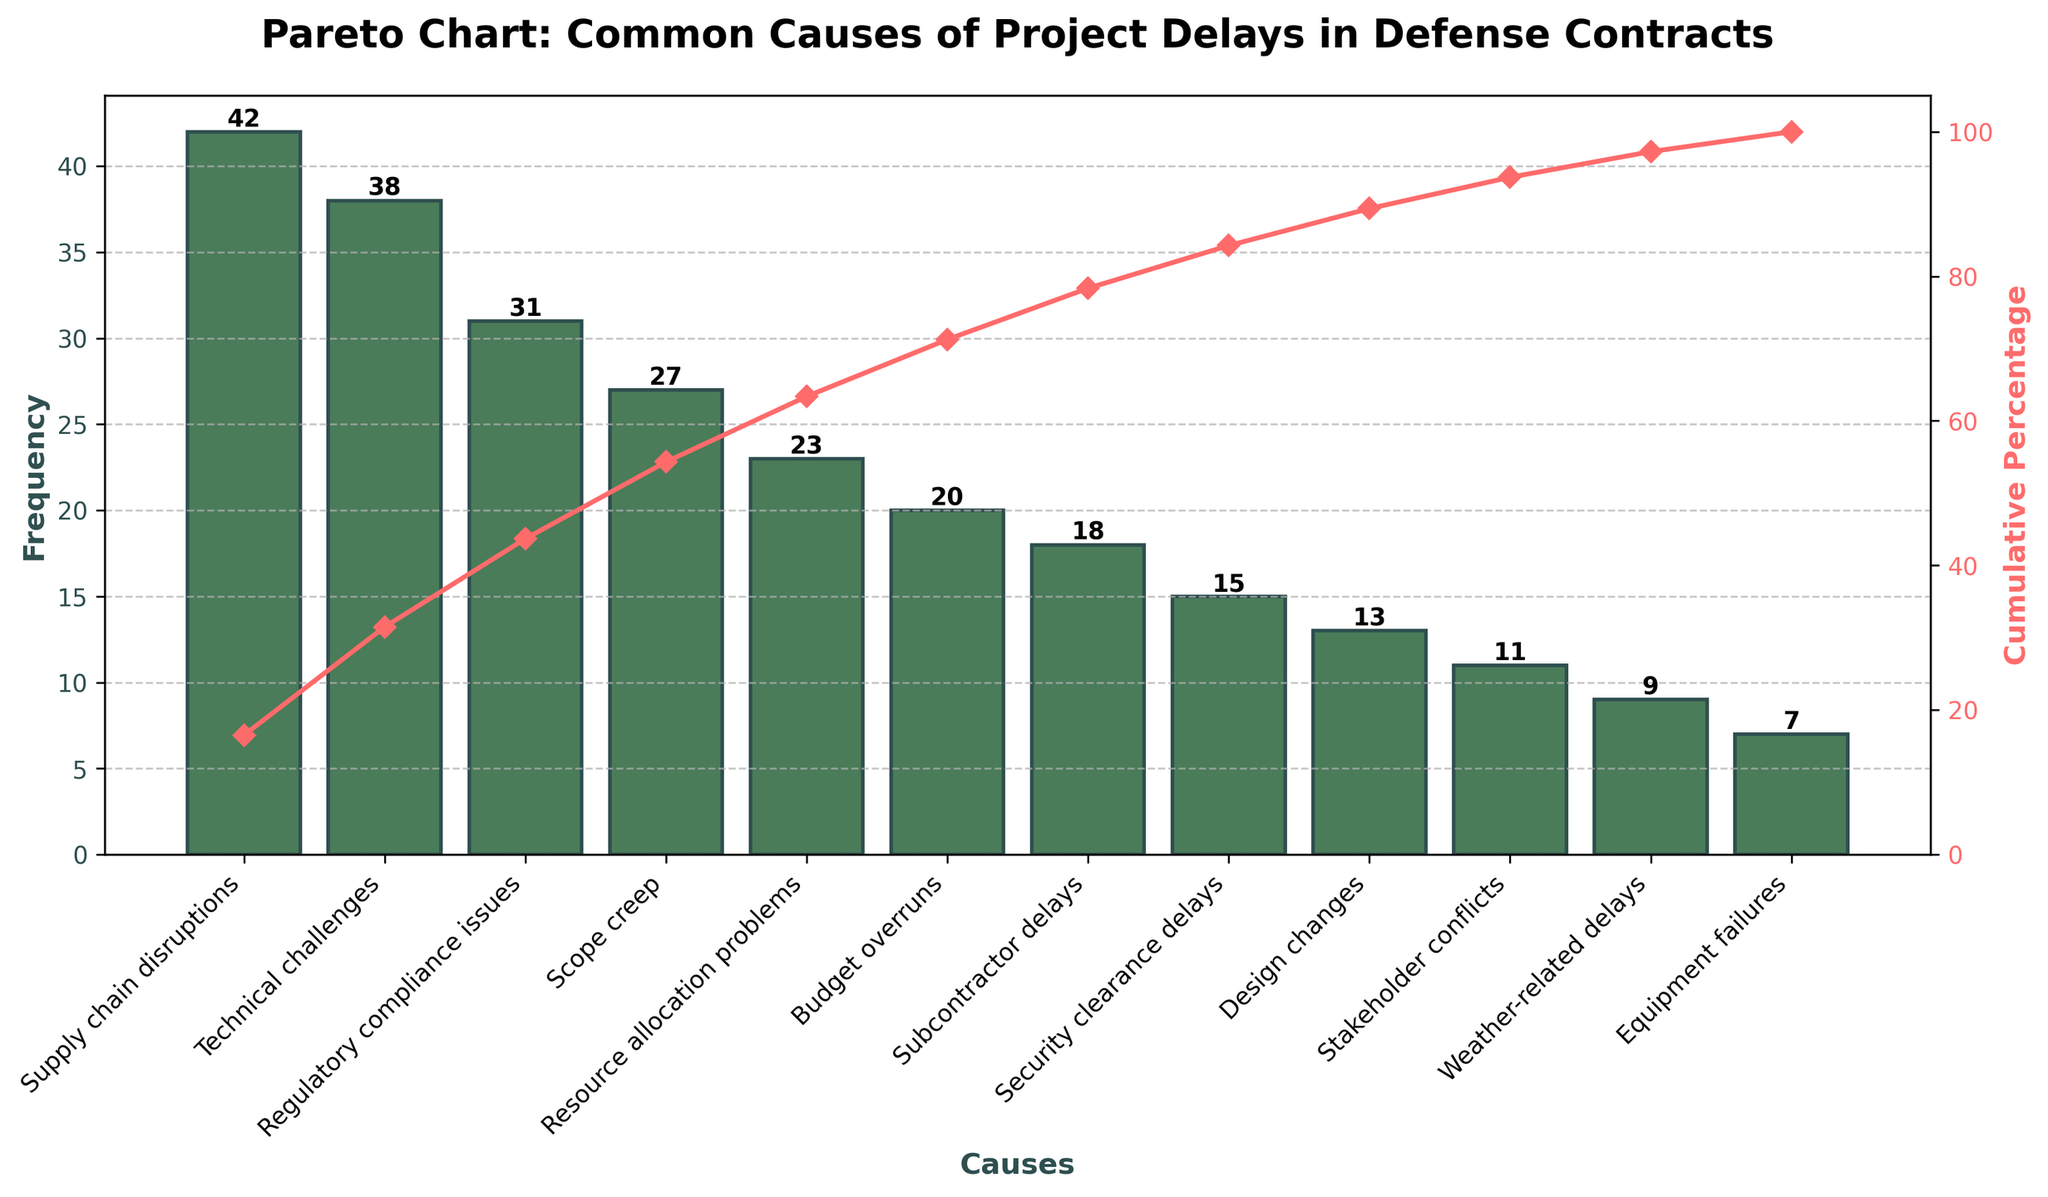What is the title of the chart? The title of the chart is located at the top and summarizes the content. The title reads "Pareto Chart: Common Causes of Project Delays in Defense Contracts."
Answer: Pareto Chart: Common Causes of Project Delays in Defense Contracts What is the most common cause of project delays in defense contracts? The cause with the highest bar in the chart represents the most frequent cause of project delays. The tallest bar corresponds to "Supply chain disruptions" with a frequency of 42.
Answer: Supply chain disruptions Which cause has the smallest frequency and how many times was it recorded? The shortest bar in the chart represents the least frequent cause of project delays. The smallest bar corresponds to "Equipment failures" with a frequency of 7.
Answer: Equipment failures, 7 What is the cumulative percentage of the top three causes combined? The cumulative percentage line shows the cumulative total for ranked causes. Adding the frequencies of the top three causes ("Supply chain disruptions": 42, "Technical challenges": 38, and "Regulatory compliance issues": 31) gives 111. Calculate (111/254) * 100 for the cumulative percentage.
Answer: 43.7% How do "Scope creep" delays compare to "Budget overruns" in terms of frequency? By comparing the heights of the respective bars for "Scope creep" and "Budget overruns," we see that "Scope creep" has a frequency of 27, and "Budget overruns" has 20. Therefore, "Scope creep" occurs more frequently than "Budget overruns."
Answer: Scope creep is more frequent What percentage of the total project delays are attributed to "Subcontractor delays" and "Security clearance delays" combined? Combine frequencies of "Subcontractor delays" (18) and "Security clearance delays" (15), resulting in a total of 33. Calculate (33/254) * 100 to determine the percentage.
Answer: 13% Which frequency causes contribute to over 50% of the cumulative percentage? Analyze the cumulative percentage line. The combined frequency of "Supply chain disruptions," "Technical challenges," "Regulatory compliance issues," and "Scope creep" exceeds 50% of the cumulative total.
Answer: Supply chain disruptions, Technical challenges, Regulatory compliance issues, Scope creep What is the cumulative frequency percentage after including "Design changes"? Find the cumulative frequency at "Design changes". Sum frequencies from top to "Design changes": 42 + 38 + 31 + 27 + 23 + 20 + 18 + 15 + 13 = 227. Calculate cumulative percentage (227/254) * 100.
Answer: 89.4% What are the effects of the causes that are least frequent? Observing the smaller bars, "Stakeholder conflicts," "Weather-related delays," and "Equipment failures" have less impact by individual frequencies of 11, 9, and 7, respectively, together they contribute to less than 11% of the cumulative delays.
Answer: Limited impact due to low frequencies 